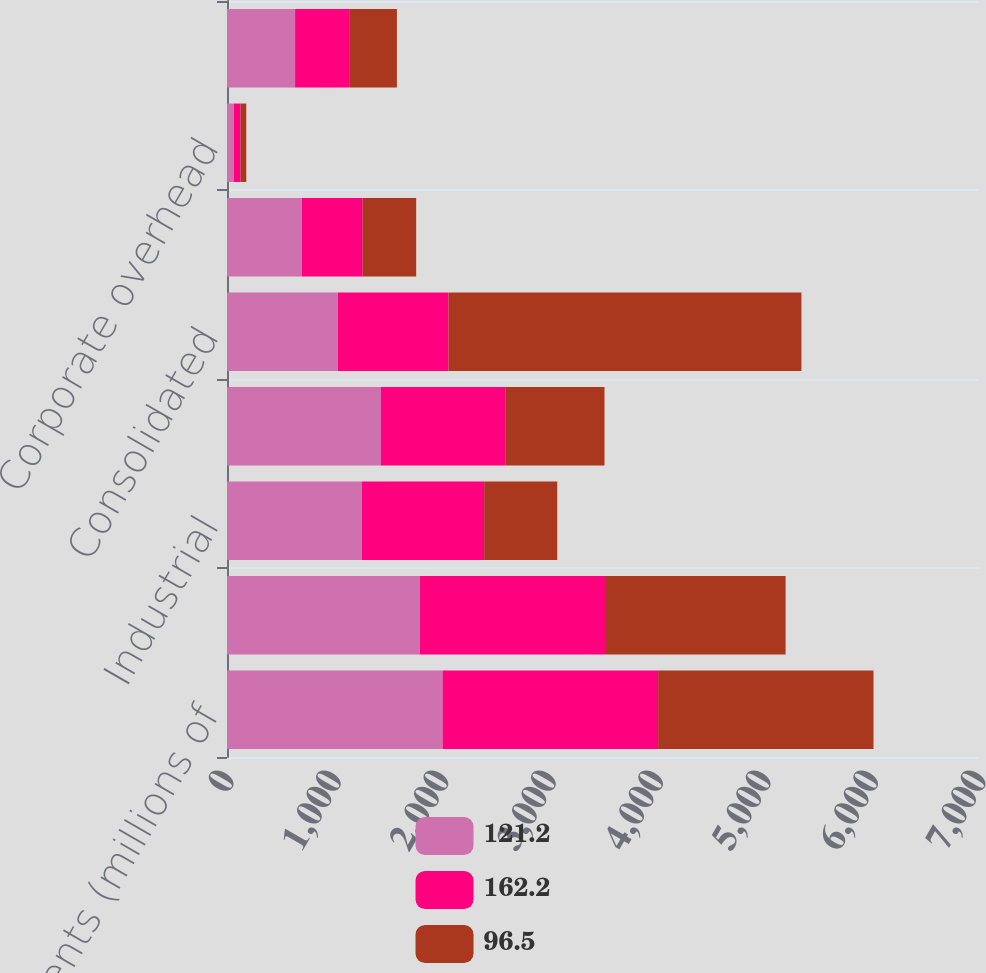Convert chart. <chart><loc_0><loc_0><loc_500><loc_500><stacked_bar_chart><ecel><fcel>Business seGments (millions of<fcel>CDIy<fcel>Industrial<fcel>Security<fcel>Consolidated<fcel>Segment profit<fcel>Corporate overhead<fcel>total<nl><fcel>121.2<fcel>2007<fcel>1795<fcel>1255.9<fcel>1432.9<fcel>1030.85<fcel>696.1<fcel>62.3<fcel>633.8<nl><fcel>162.2<fcel>2006<fcel>1723.9<fcel>1137.7<fcel>1157<fcel>1030.85<fcel>566.6<fcel>63.3<fcel>503.3<nl><fcel>96.5<fcel>2005<fcel>1680.8<fcel>680.5<fcel>924<fcel>3285.3<fcel>498.3<fcel>53.8<fcel>444.5<nl></chart> 